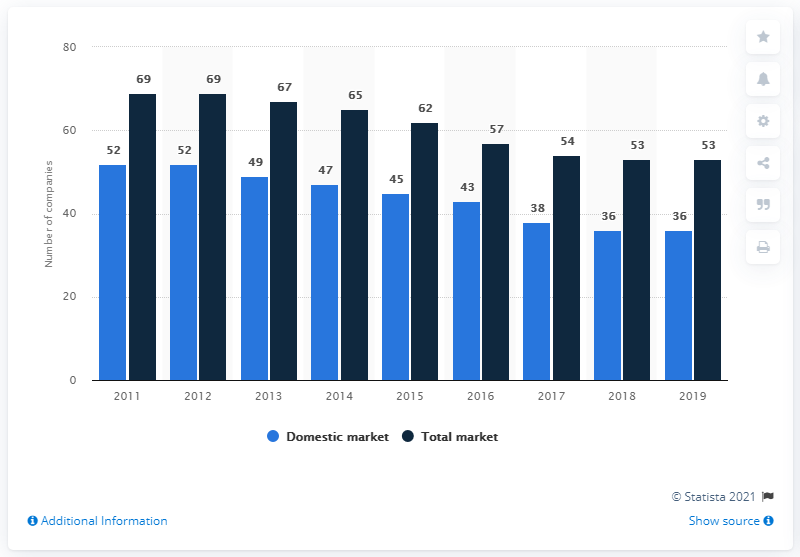List a handful of essential elements in this visual. As of the end of 2019, there were 36 insurance companies operating on the Greek domestic market. In the year 2018, there were 36 companies operating on the insurance domestic market. The maximum and minimum number of domestic insurance companies in Greece between 2011 and 2019 was 16, with the minimum being 16 and the maximum being 16. 